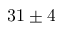Convert formula to latex. <formula><loc_0><loc_0><loc_500><loc_500>3 1 \pm 4</formula> 